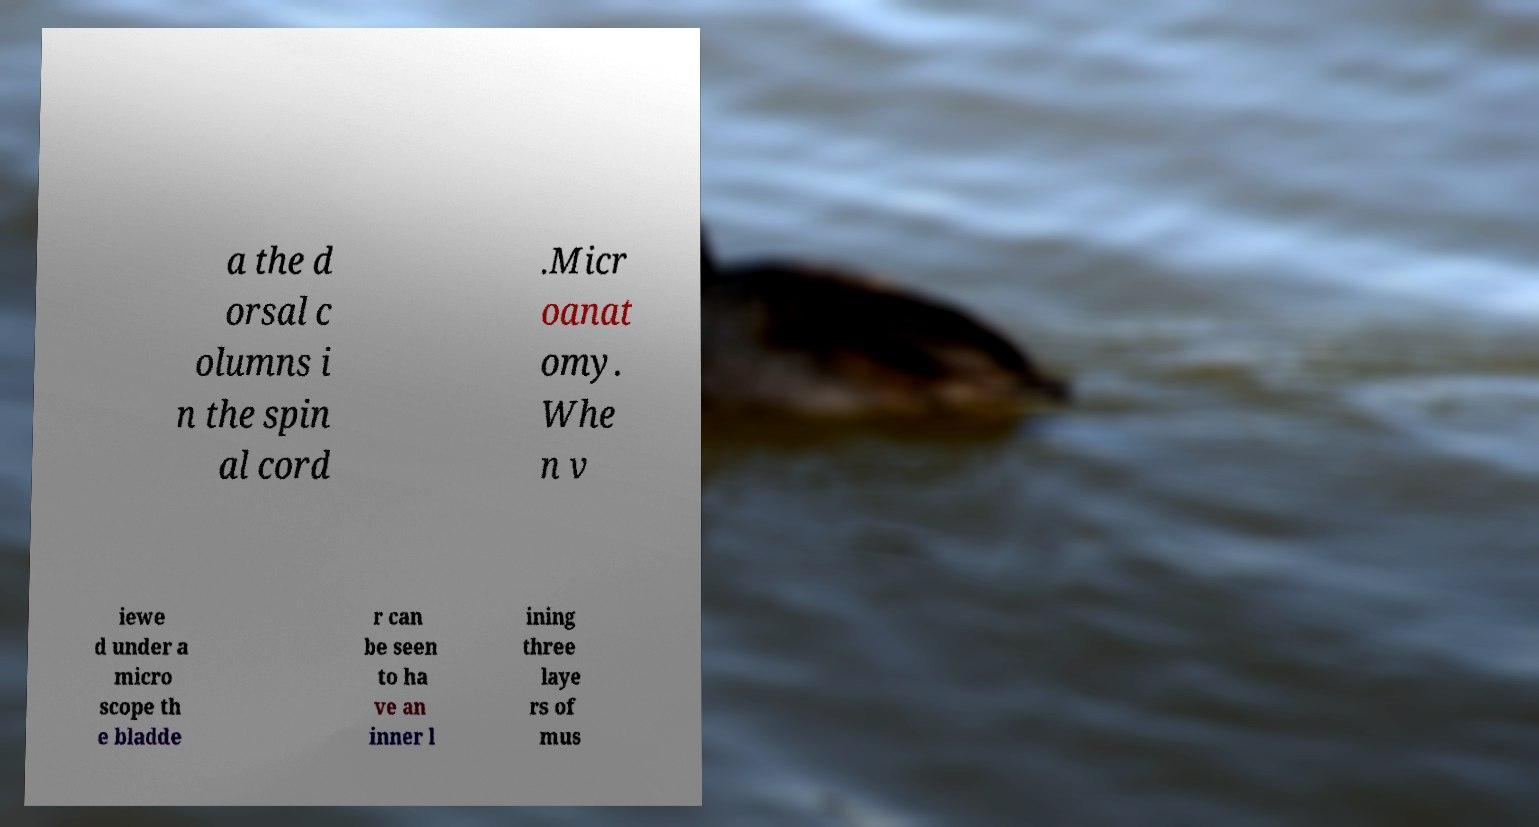Can you read and provide the text displayed in the image?This photo seems to have some interesting text. Can you extract and type it out for me? a the d orsal c olumns i n the spin al cord .Micr oanat omy. Whe n v iewe d under a micro scope th e bladde r can be seen to ha ve an inner l ining three laye rs of mus 